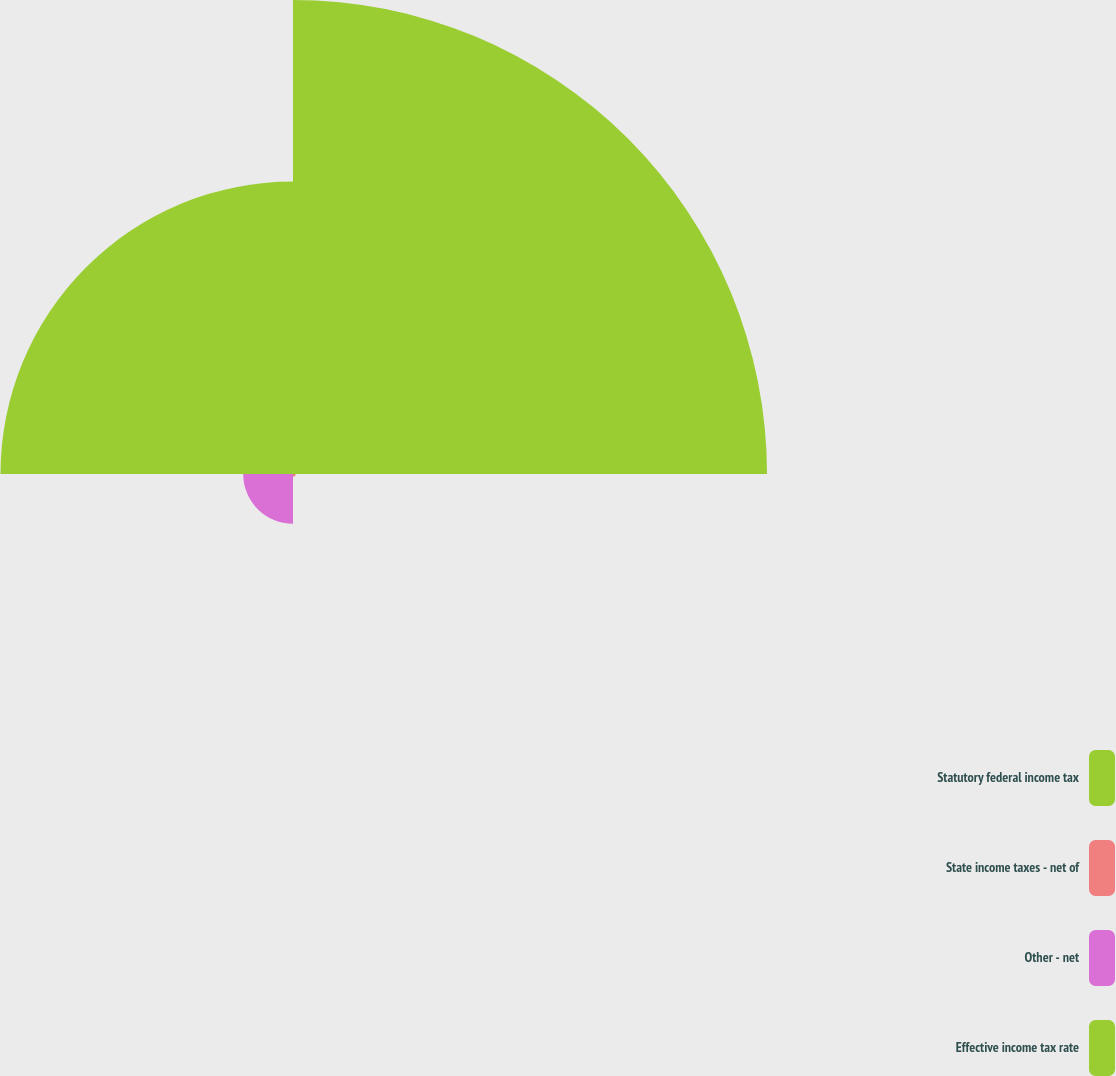Convert chart to OTSL. <chart><loc_0><loc_0><loc_500><loc_500><pie_chart><fcel>Statutory federal income tax<fcel>State income taxes - net of<fcel>Other - net<fcel>Effective income tax rate<nl><fcel>57.87%<fcel>0.33%<fcel>6.08%<fcel>35.71%<nl></chart> 